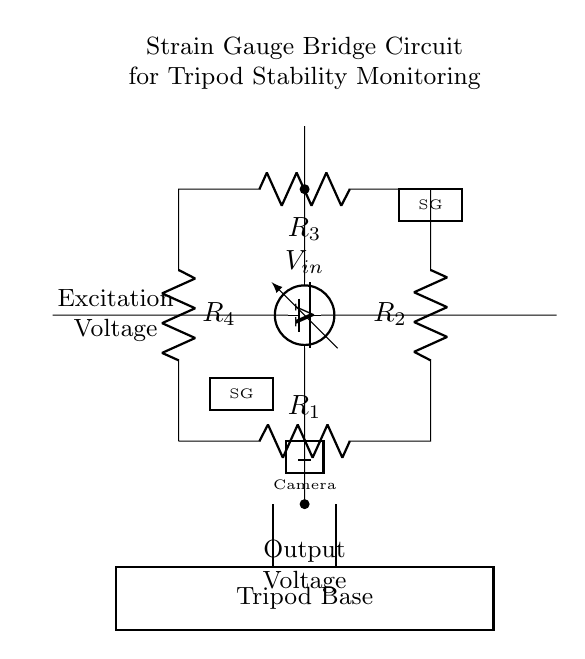What is the role of the resistors in the bridge? The resistors R1, R2, R3, and R4 form a Wheatstone bridge configuration, where their values determine the voltage output based on the resistance changes from the strain gauges (SGs) due to applied force or weight.
Answer: They balance the bridge What is the excitation voltage in this circuit? The excitation voltage is provided by the battery, labeled as Vin, which supplies the necessary electrical energy to the bridge circuit for operation.
Answer: Vin How many strain gauges are used in this circuit? Two strain gauges are depicted in the circuit diagram, influenced by the weight or force applied to the tripod, which are crucial for accurate readings.
Answer: Two What does the voltmeter measure in this circuit? The voltmeter measures the output voltage across the bridge, which indicates any imbalance caused by differing resistance levels from the attached strain gauges.
Answer: Output Voltage Which component provides power to the circuit? The battery, labeled as Vin, acts as the power source for the circuit, supplying the required excitation voltage to the bridge and enabling it to function properly.
Answer: Battery What happens if one strain gauge experiences significant strain? If one strain gauge experiences significant strain, it alters its resistance more than the other, causing an imbalance in the bridge and resulting in a measurable change in output voltage, indicating the stabilization of the tripod.
Answer: Imbalance occurs What is the purpose of the bridge circuit in this setup? The bridge circuit's primary purpose is to monitor the stability of the tripod and ensure proper weight distribution by comparing the resistive changes from the strain gauges due to weight.
Answer: To monitor stability and weight distribution 